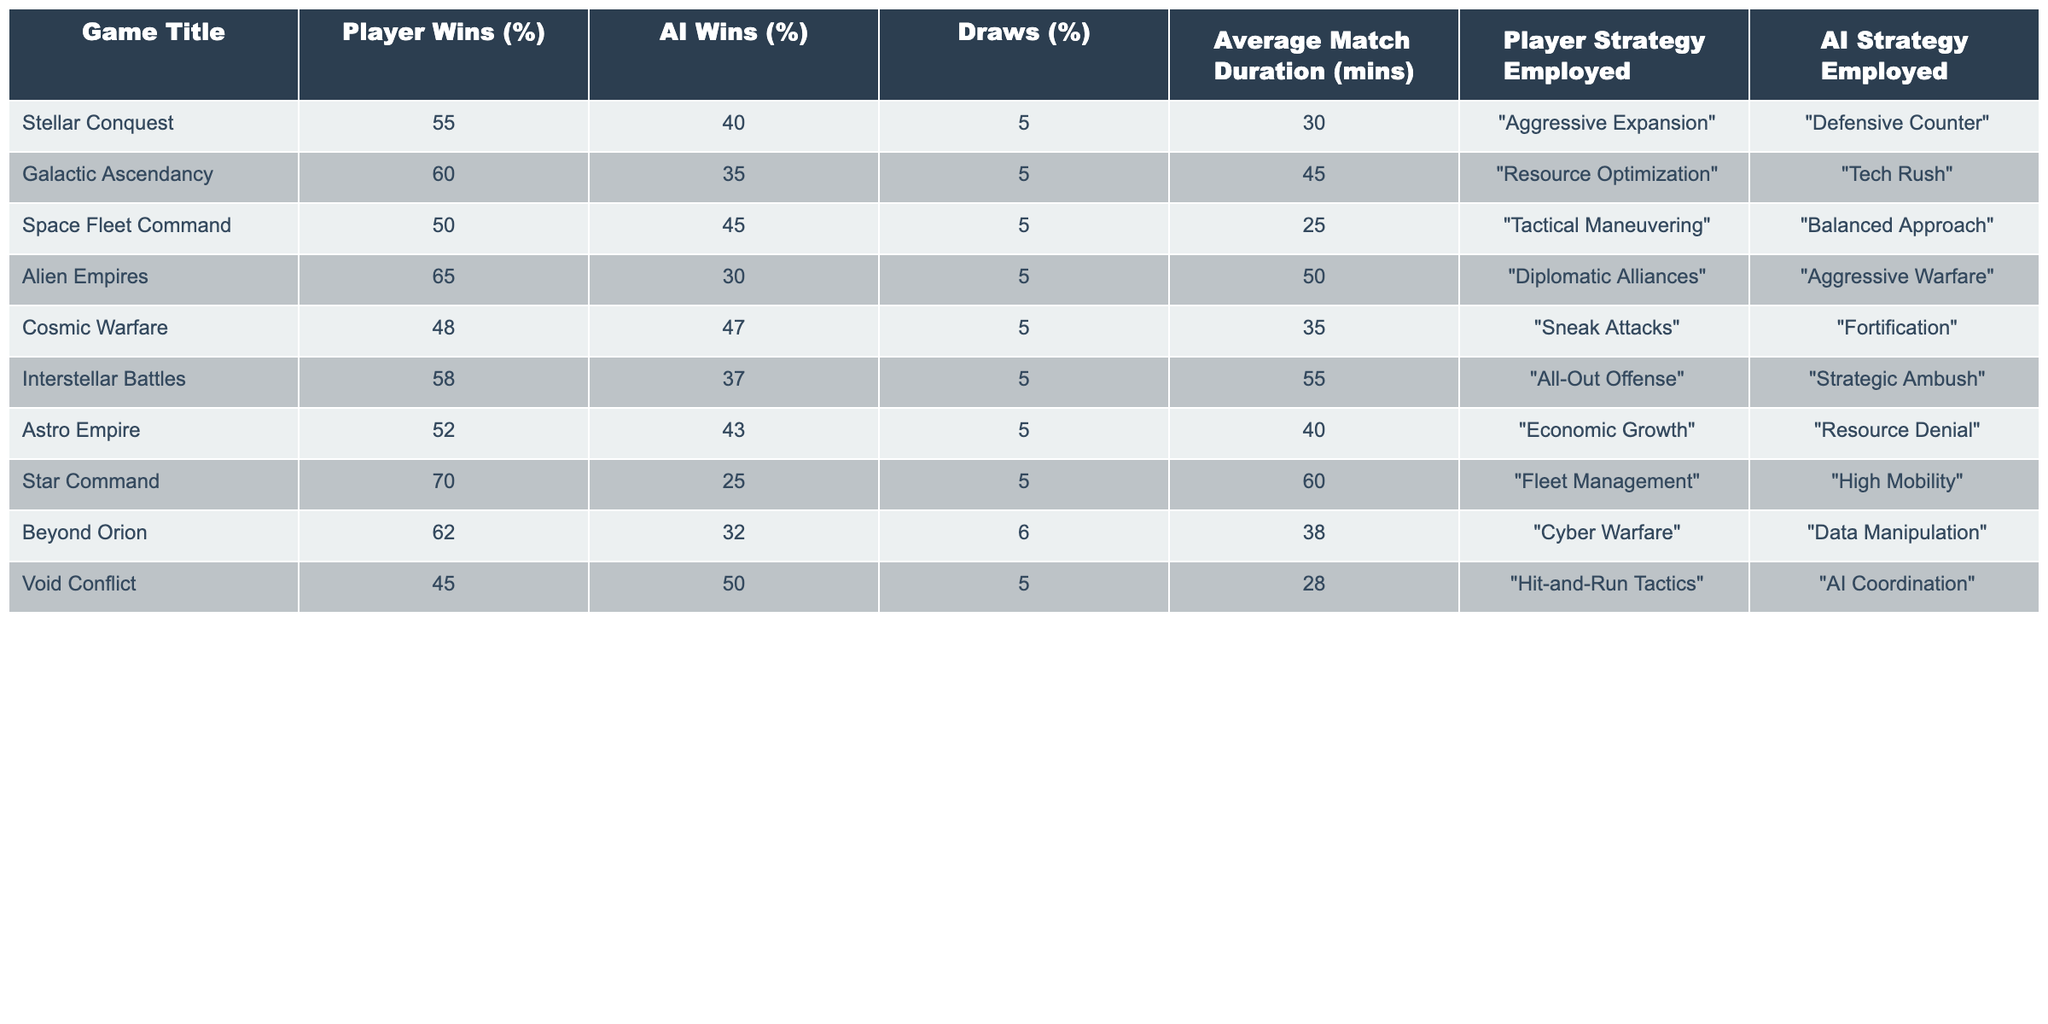What is the highest percentage of player wins in the table? The highest percentage of player wins is 70%, found for the game "Star Command."
Answer: 70% Which game has the lowest percentage of AI wins? The lowest percentage of AI wins is 25%, which is from the game "Star Command."
Answer: 25% What is the average match duration across all games? The average match duration is calculated by summing up all durations (30 + 45 + 25 + 50 + 35 + 55 + 40 + 60 + 38 + 28 =  408) and dividing by the number of games (10): 408 / 10 = 40.8 minutes.
Answer: 40.8 mins Did any game result in more draws than AI wins? No, all games have the percentage of draws equal to or lower than AI wins.
Answer: No What is the ratio of player wins to AI wins for "Galactic Ascendancy"? The player wins are 60% and AI wins are 35%, giving a ratio of 60:35, which simplifies to 12:7.
Answer: 12:7 Which strategy leads to the highest percentage of AI wins, and what is that percentage? The AI strategy with the highest wins is "AI Coordination" in the game "Void Conflict," which has 50% AI wins.
Answer: 50% What difference in average match duration exists between "Alien Empires" and "Void Conflict"? The average duration for "Alien Empires" is 50 minutes and for "Void Conflict" is 28 minutes; the difference is 50 - 28 = 22 minutes.
Answer: 22 minutes Which two games have the closest percentages of player wins? "Stellar Conquest" has 55% and "Astro Empire" has 52%, resulting in a difference of 3%.
Answer: 3% If the player employed “Defensive Counter,” what is the corresponding AI strategy and its win percentage? The AI strategy corresponding to “Defensive Counter” is “Aggressive Expansion” which has a win percentage of 40%.
Answer: 40% Is there any game where the percentages of player and AI wins are very close together? Yes, "Space Fleet Command" has player wins at 50% and AI wins at 45%, a difference of only 5%.
Answer: Yes 